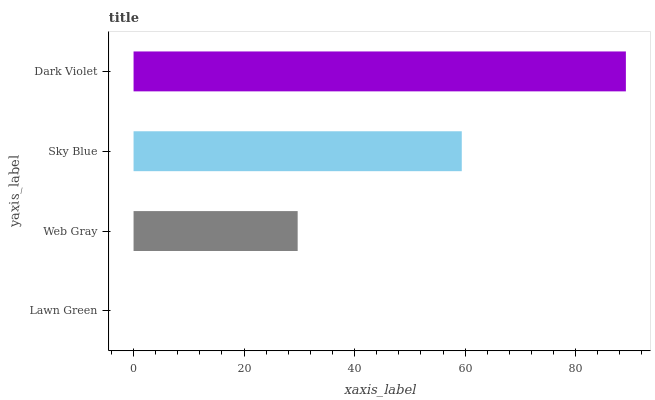Is Lawn Green the minimum?
Answer yes or no. Yes. Is Dark Violet the maximum?
Answer yes or no. Yes. Is Web Gray the minimum?
Answer yes or no. No. Is Web Gray the maximum?
Answer yes or no. No. Is Web Gray greater than Lawn Green?
Answer yes or no. Yes. Is Lawn Green less than Web Gray?
Answer yes or no. Yes. Is Lawn Green greater than Web Gray?
Answer yes or no. No. Is Web Gray less than Lawn Green?
Answer yes or no. No. Is Sky Blue the high median?
Answer yes or no. Yes. Is Web Gray the low median?
Answer yes or no. Yes. Is Web Gray the high median?
Answer yes or no. No. Is Lawn Green the low median?
Answer yes or no. No. 